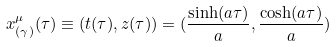<formula> <loc_0><loc_0><loc_500><loc_500>x ^ { \mu } _ { ( \gamma ) } ( \tau ) \equiv ( t ( \tau ) , z ( \tau ) ) = ( \frac { \sinh ( a \tau ) } { a } , \frac { \cosh ( a \tau ) } { a } )</formula> 